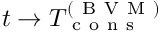Convert formula to latex. <formula><loc_0><loc_0><loc_500><loc_500>t \rightarrow T _ { c o n s } ^ { ( B V M ) }</formula> 